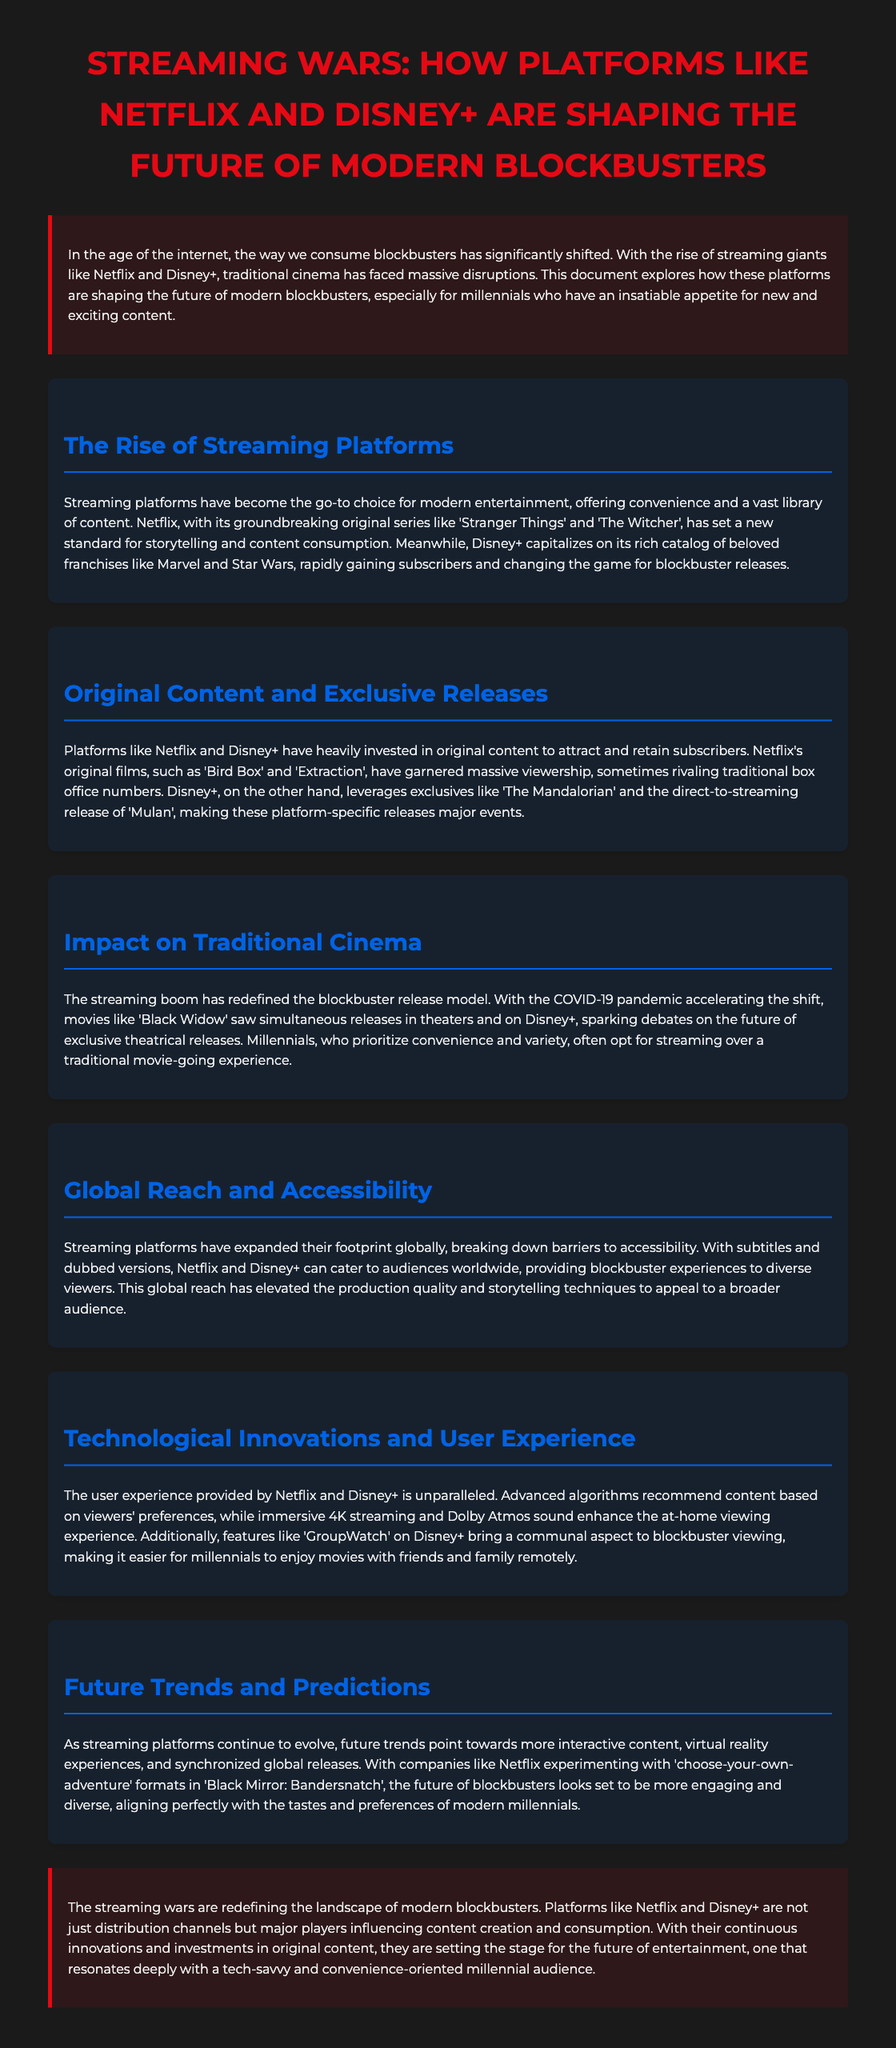what is the primary focus of the document? The introduction explicitly states that the document explores how platforms like Netflix and Disney+ are shaping the future of modern blockbusters.
Answer: streaming platforms which Netflix original series is mentioned as a groundbreaking example? The content section highlights 'Stranger Things' as a groundbreaking series that set a new standard for storytelling.
Answer: Stranger Things what movie did Disney+ release directly to streaming? The document states that 'Mulan' was released directly to streaming on Disney+.
Answer: Mulan how do Netflix and Disney+ enhance user experience? The document mentions advanced algorithms and immersive features to improve the user experience for viewers.
Answer: algorithms what major event accelerated the shift in blockbuster releases? The content discusses the COVID-19 pandemic as a significant event that accelerated changes in the release model.
Answer: COVID-19 pandemic what is one predicted future trend for streaming platforms? The document indicates that future trends may include more interactive content and virtual reality experiences.
Answer: interactive content which Disney+ exclusive is cited as a major event release? The document mentions 'The Mandalorian' specifically as an exclusive release event for Disney+.
Answer: The Mandalorian what demographic is emphasized in relation to convenience and variety? The text highlights millennials as the demographic that prioritizes convenience and variety in content consumption.
Answer: millennials 